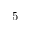Convert formula to latex. <formula><loc_0><loc_0><loc_500><loc_500>5</formula> 